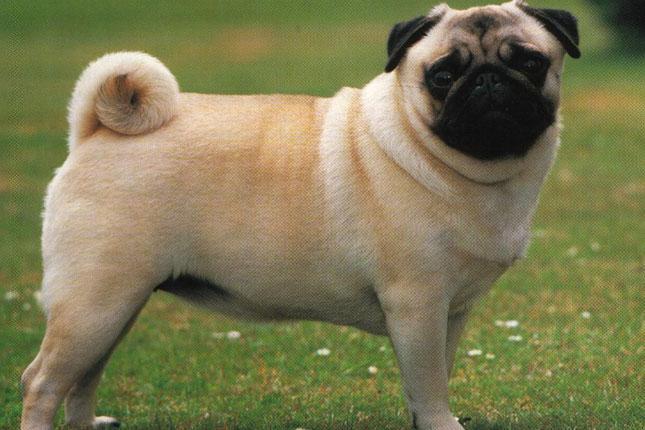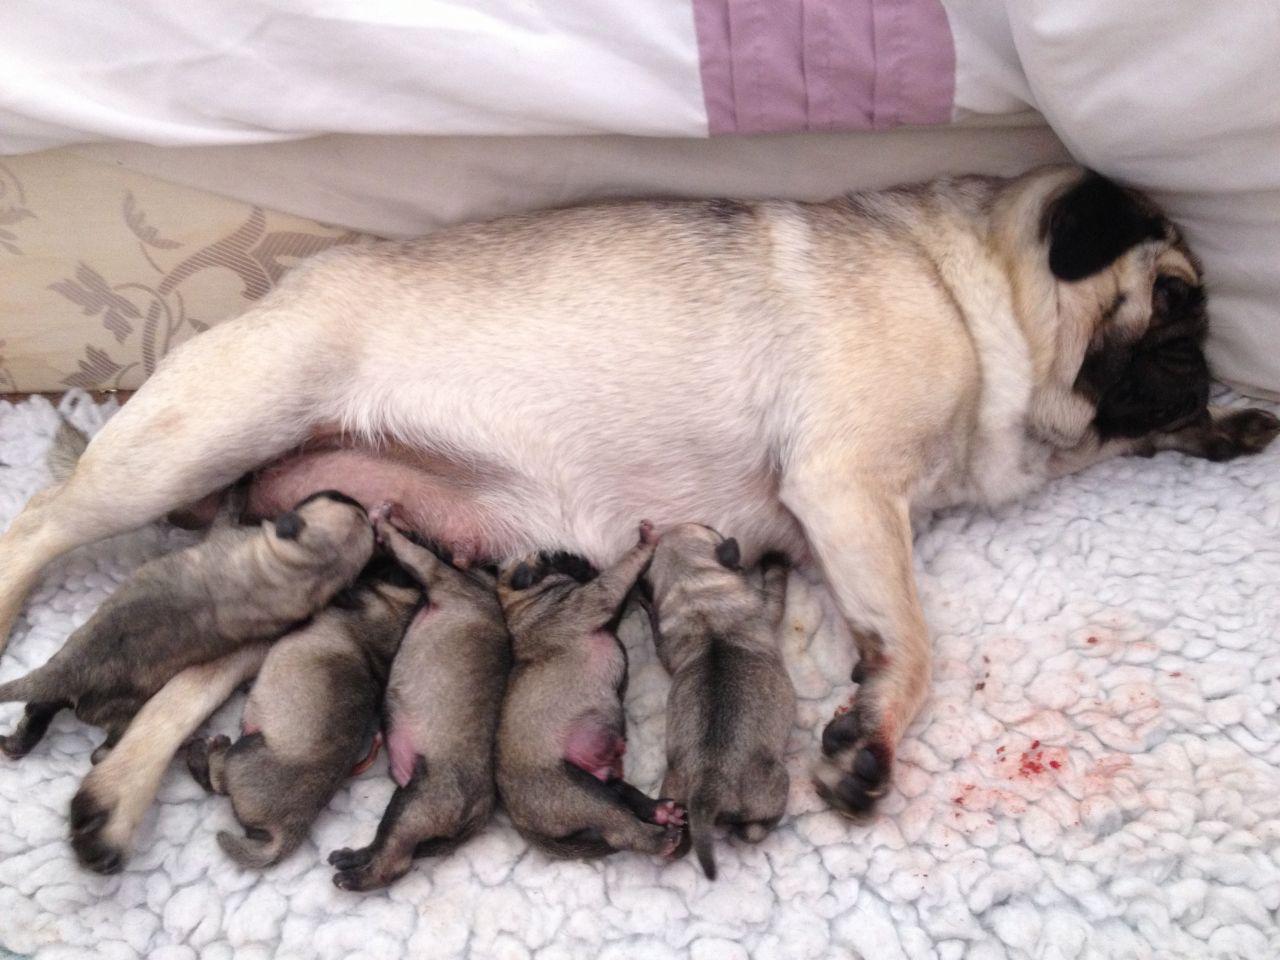The first image is the image on the left, the second image is the image on the right. Examine the images to the left and right. Is the description "Each image shows one pug posed outdoors, and one image shows a standing pug while the other shows a reclining pug." accurate? Answer yes or no. No. The first image is the image on the left, the second image is the image on the right. For the images displayed, is the sentence "Exactly one dog is in the grass." factually correct? Answer yes or no. Yes. 